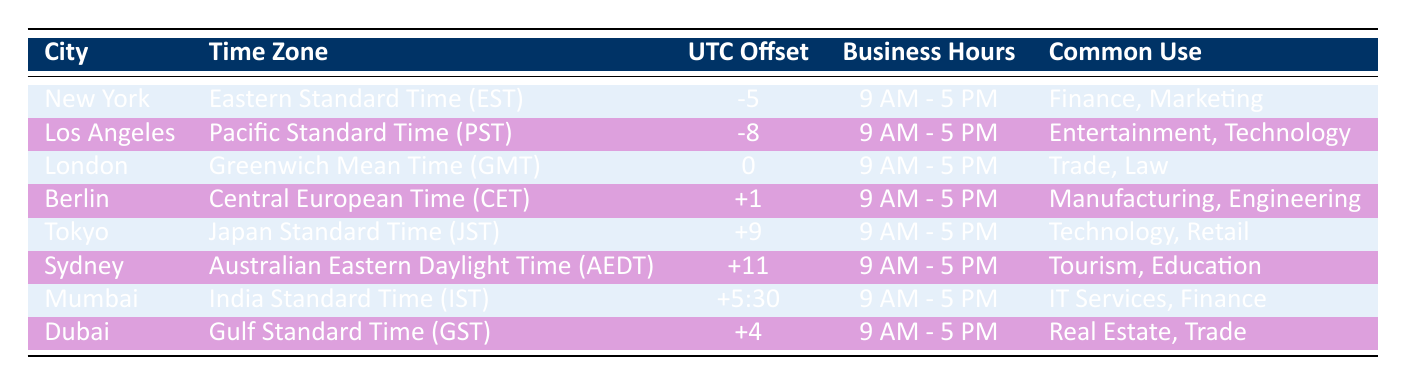What is the UTC offset for Tokyo? Based on the table, Tokyo is listed with the UTC offset of +9.
Answer: +9 Which city is in the Eastern Standard Time zone? The table indicates that New York is in the Eastern Standard Time (EST) time zone.
Answer: New York What are the common uses for businesses in London? The table states that the common uses for businesses in London include Trade and Law.
Answer: Trade, Law Is Mumbai's business hours the same as the rest of the cities listed? All cities have business hours from 9 AM to 5 PM listed in the table, including Mumbai, which confirms the same hours.
Answer: Yes Which city has the latest time zone? Sydney, with a UTC offset of +11, has the latest time zone when compared to the cities listed.
Answer: Sydney What is the difference in UTC offset between Los Angeles and Berlin? Los Angeles has a UTC offset of -8 while Berlin has +1. The difference is calculated as 1 - (-8) = 9.
Answer: 9 How many cities have business operations in the technology sector? The cities listed in the table that have a common use in technology are Los Angeles, Tokyo, and Berlin, totaling three cities.
Answer: 3 Are the business hours for Dubai different than the 9 AM to 5 PM schedule? The table shows Dubai's business hours are listed as 9 AM to 5 PM, which matches the common business hours presented.
Answer: No If a business meeting is held at 3 PM in New York, what time will it be in London? New York is at UTC -5 and London is at UTC 0. The time difference is 5 hours. Therefore, 3 PM in New York is 8 PM in London.
Answer: 8 PM 